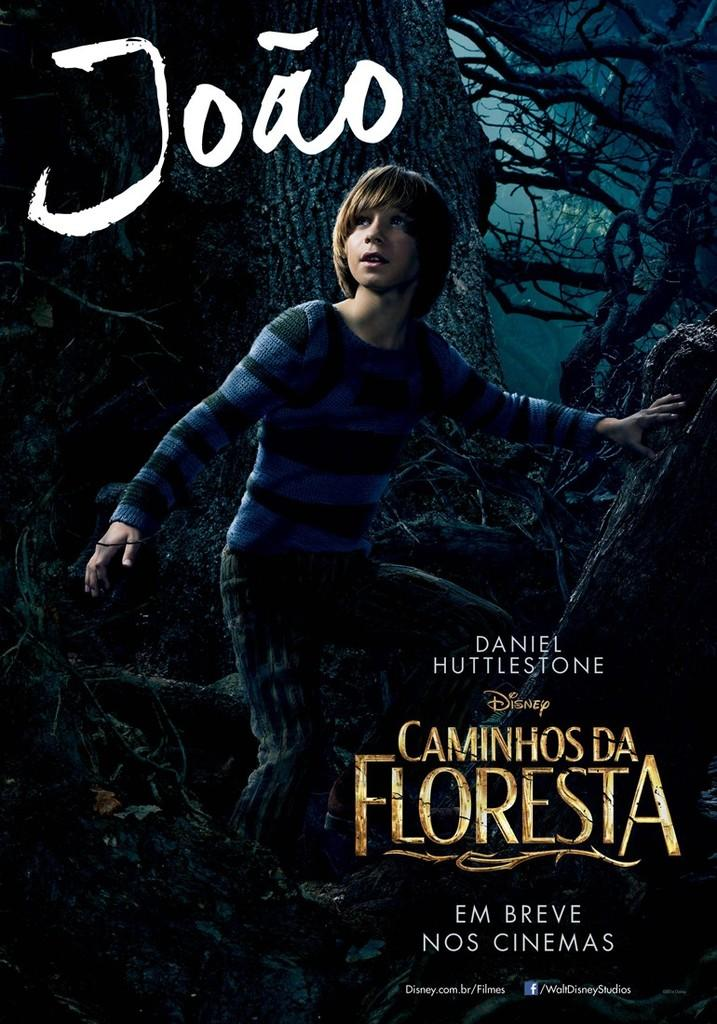Provide a one-sentence caption for the provided image. Daniel Huttlestone stars in Disneys Caminhosda Floresta in the cinemas. 